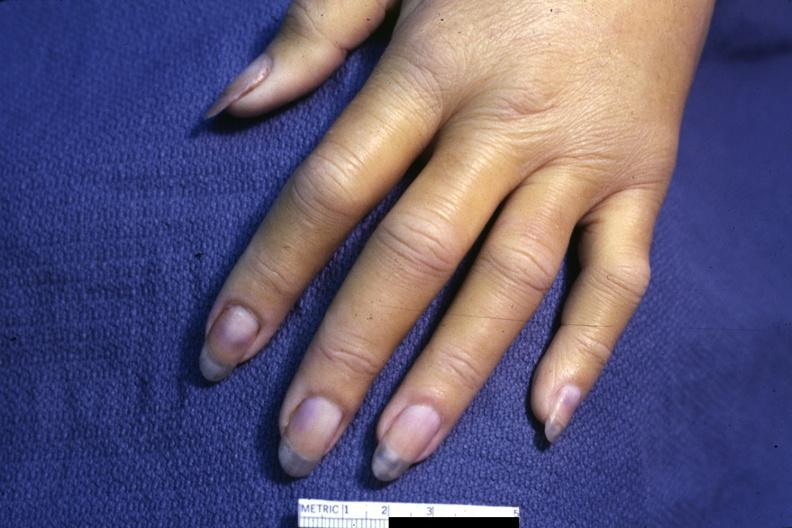how does case of dic not bad photo require room to see subtle distal phalangeal cyanosis?
Answer the question using a single word or phrase. Dark 